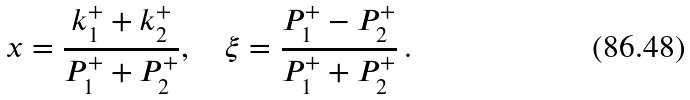<formula> <loc_0><loc_0><loc_500><loc_500>x = \frac { k _ { 1 } ^ { + } + k _ { 2 } ^ { + } } { P _ { 1 } ^ { + } + P _ { 2 } ^ { + } } , \quad \xi = \frac { P _ { 1 } ^ { + } - P _ { 2 } ^ { + } } { P _ { 1 } ^ { + } + P _ { 2 } ^ { + } } \, .</formula> 